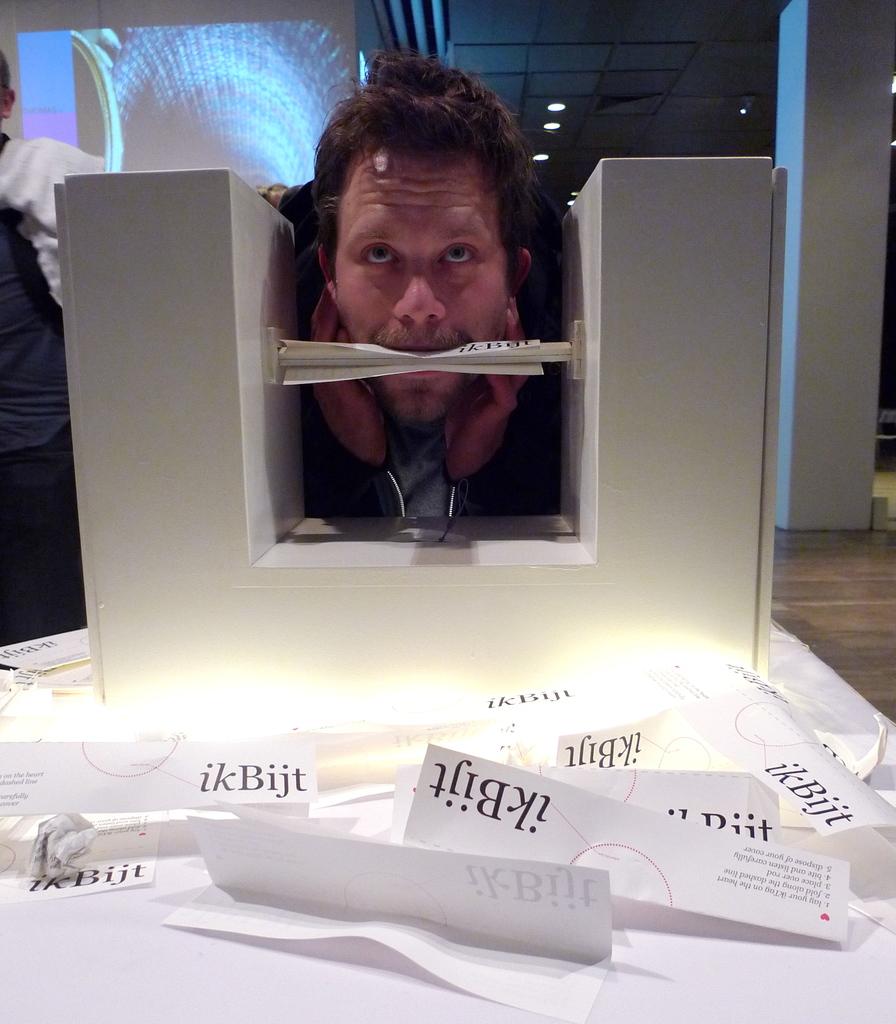What is the title on these paper slips?
Your response must be concise. Ikbijt. 